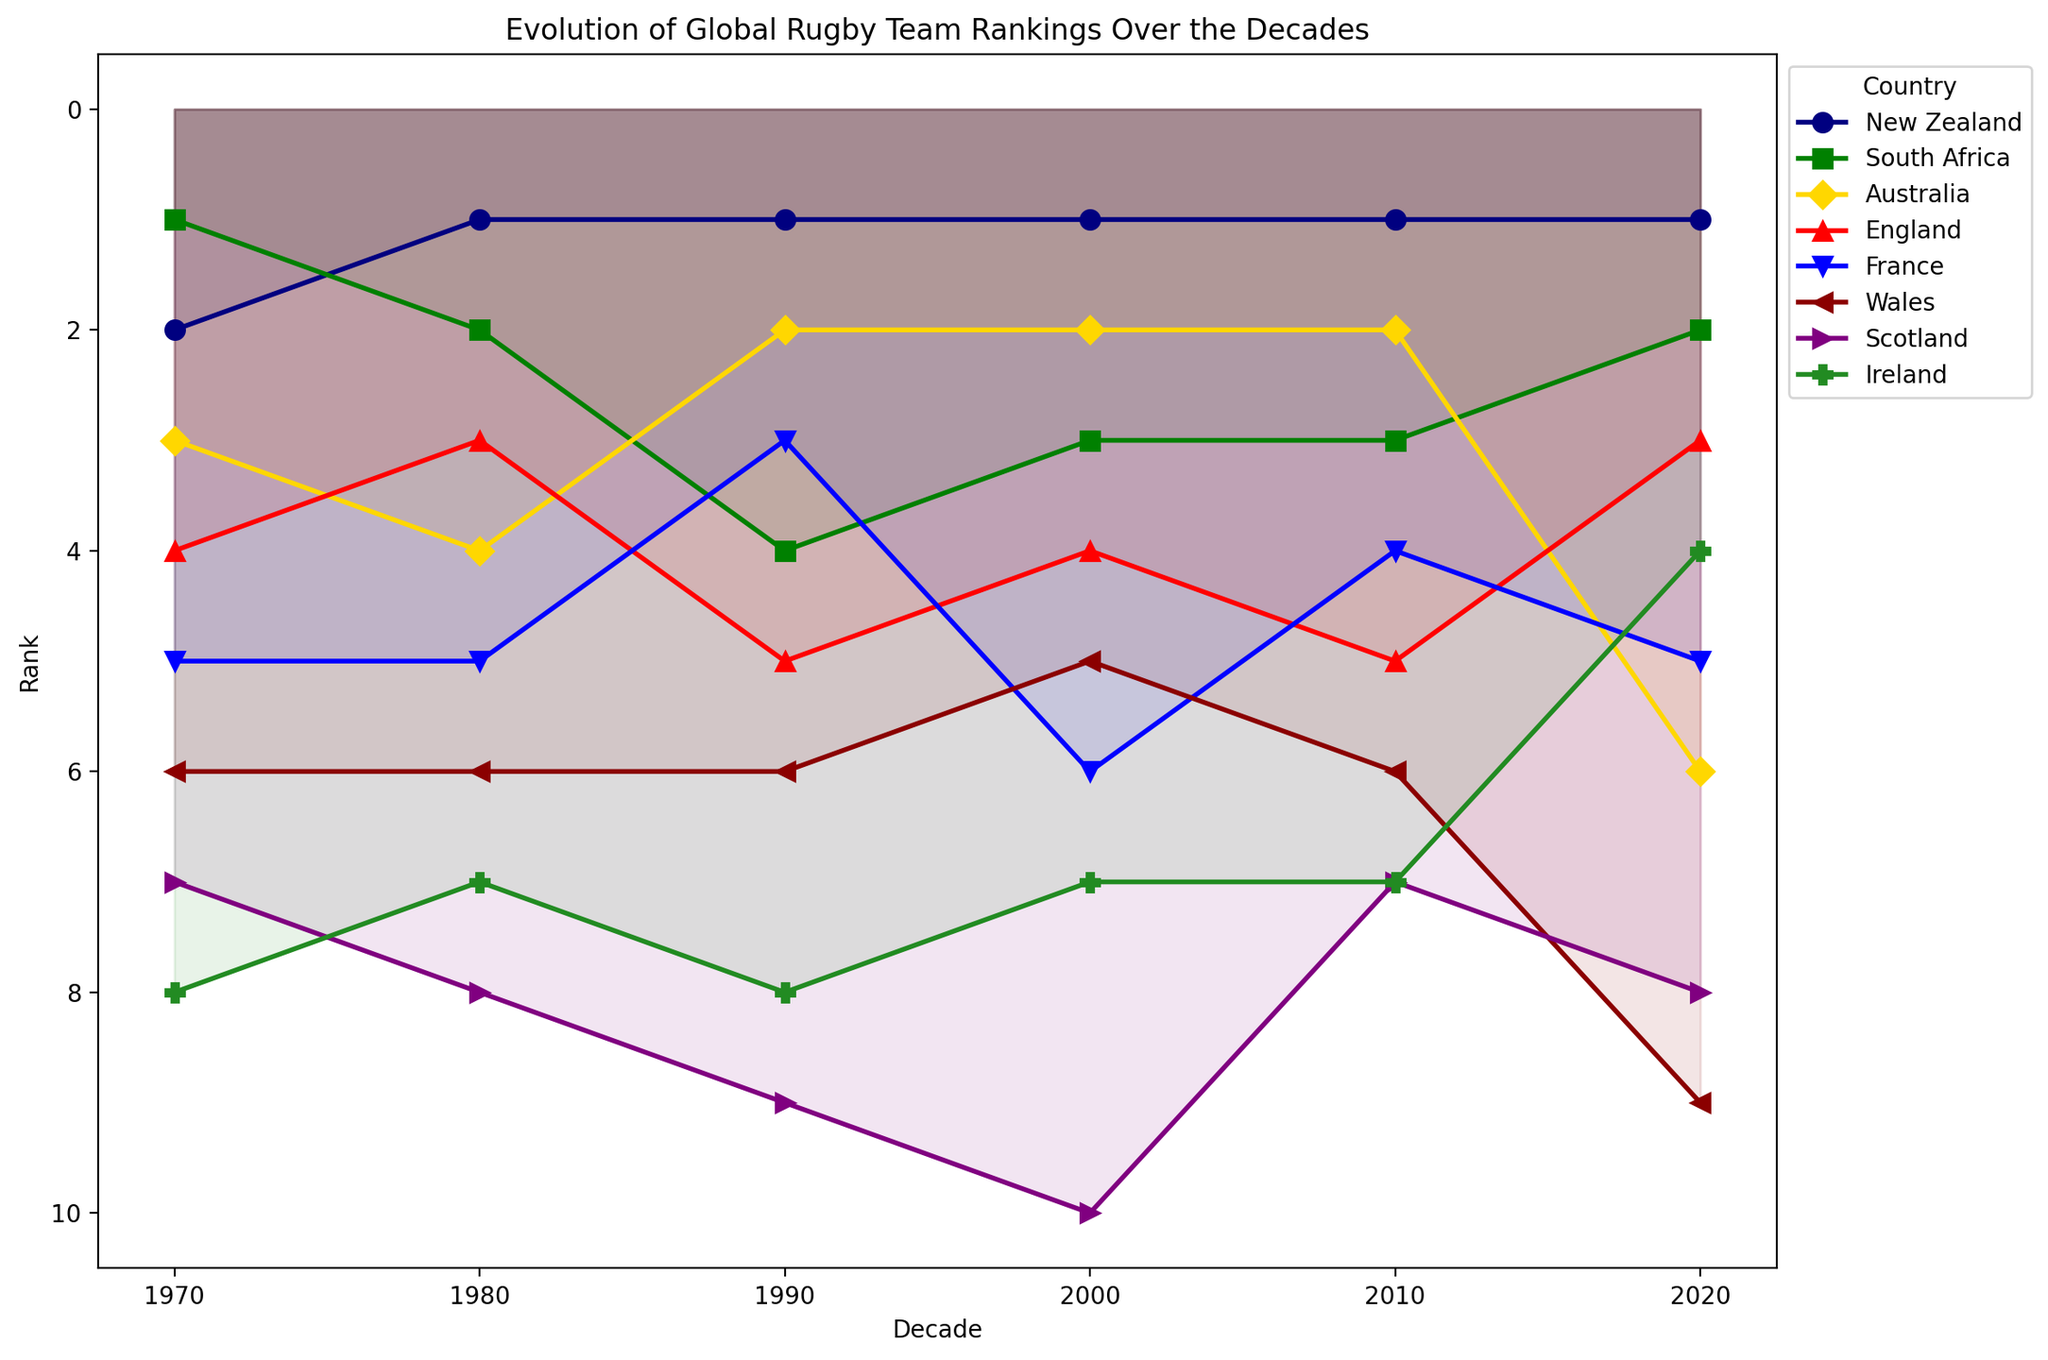Which country has maintained the top rank most consistently over the decades? By examining the evolution lines, we can see that New Zealand has been consistently ranked 1st in every decade.
Answer: New Zealand Has South Africa ever been ranked higher than New Zealand in any decade, and if so, when? South Africa was ranked higher than New Zealand in the 1970s, where South Africa was 1st and New Zealand was 2nd. In all other decades, New Zealand was ranked higher or equal.
Answer: Yes, in the 1970s Among Australia and England, which country has had a higher average rank from 1970 to 2020? Calculate the average rank for both countries over the decades. Australia's ranks: (3+4+2+2+2+6)/6 = 3.17. England's ranks: (4+3+5+4+5+3)/6 = 4.
Answer: Australia What is the trend in the rank of France over the decades? France started at 5th place in 1970, remained there in the 1980s, climbed to 3rd in the 1990s, dropped to 6th in 2000, improved to 4th in the 2010s, and settled at 5th in the 2020s. This shows fluctuations with slight improvement towards the end.
Answer: Fluctuating with improvement in recent decades Which team shows the most significant decline in ranking from 1970 to 2020? Compare the change in rank for each country between 1970 and 2020. Wales declines from 6th to 9th (a drop of 3 positions), whereas other teams have lesser declines or improvements.
Answer: Wales Comparing the 1990 and 2010 decades, which country showed the most significant improvement in ranking? Examine the chart to identify any notable rise from 1990 to 2010 for each country. South Africa remained at 3rd, whereas Ireland improved from 8th to 7th. No significant improvements are noticeable for other countries.
Answer: No country showed significant improvement Looking at the 2000s and 2020s, did England improve or deteriorate in their rankings? Compare England's rank in 2000 (4th) and 2020 (3rd). The rank improved by one position.
Answer: Improved What trend do Scotland's rankings indicate over the decades? Scotland continuously declined from 1970 (7th) to 2000 (10th), then improved slightly by 2010 (7th) and maintained a similar position (8th) by 2020.
Answer: Declined initially, slight improvement later Between Ireland and Wales, which country had a better rank in 2020? Refer to the rank positions for both countries in 2020. Ireland is 4th and Wales is 9th.
Answer: Ireland In which decade did Australia achieve the highest rank, and what was the rank? Australia had its highest rank in the 1990s and 2000s, where it ranked 2nd.
Answer: 1990s and 2000s, rank 2 